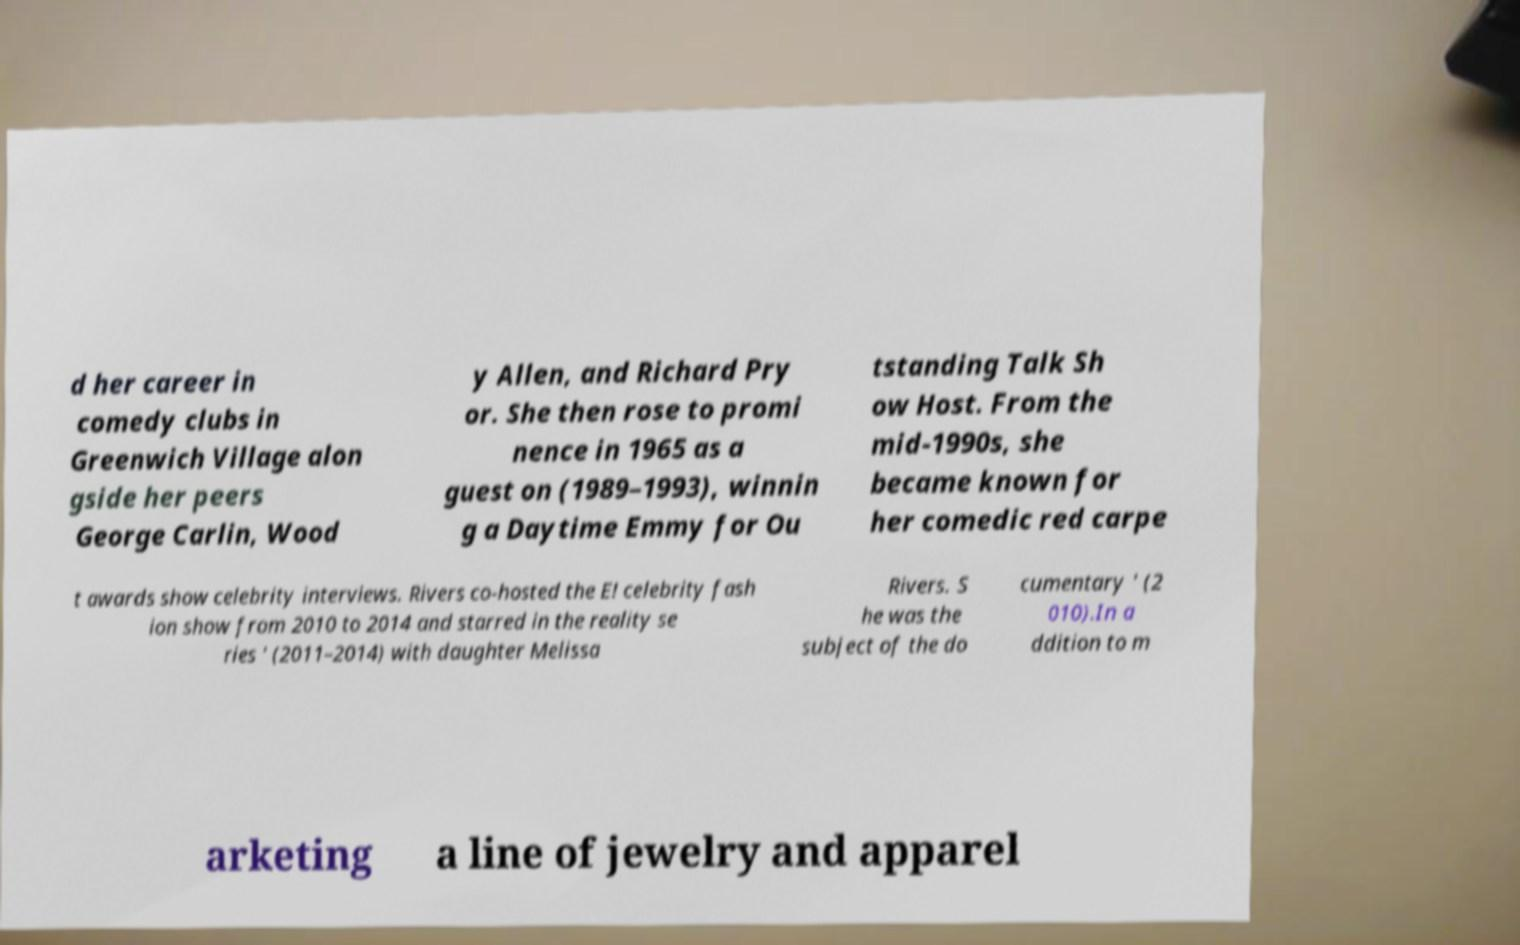What messages or text are displayed in this image? I need them in a readable, typed format. d her career in comedy clubs in Greenwich Village alon gside her peers George Carlin, Wood y Allen, and Richard Pry or. She then rose to promi nence in 1965 as a guest on (1989–1993), winnin g a Daytime Emmy for Ou tstanding Talk Sh ow Host. From the mid-1990s, she became known for her comedic red carpe t awards show celebrity interviews. Rivers co-hosted the E! celebrity fash ion show from 2010 to 2014 and starred in the reality se ries ' (2011–2014) with daughter Melissa Rivers. S he was the subject of the do cumentary ' (2 010).In a ddition to m arketing a line of jewelry and apparel 